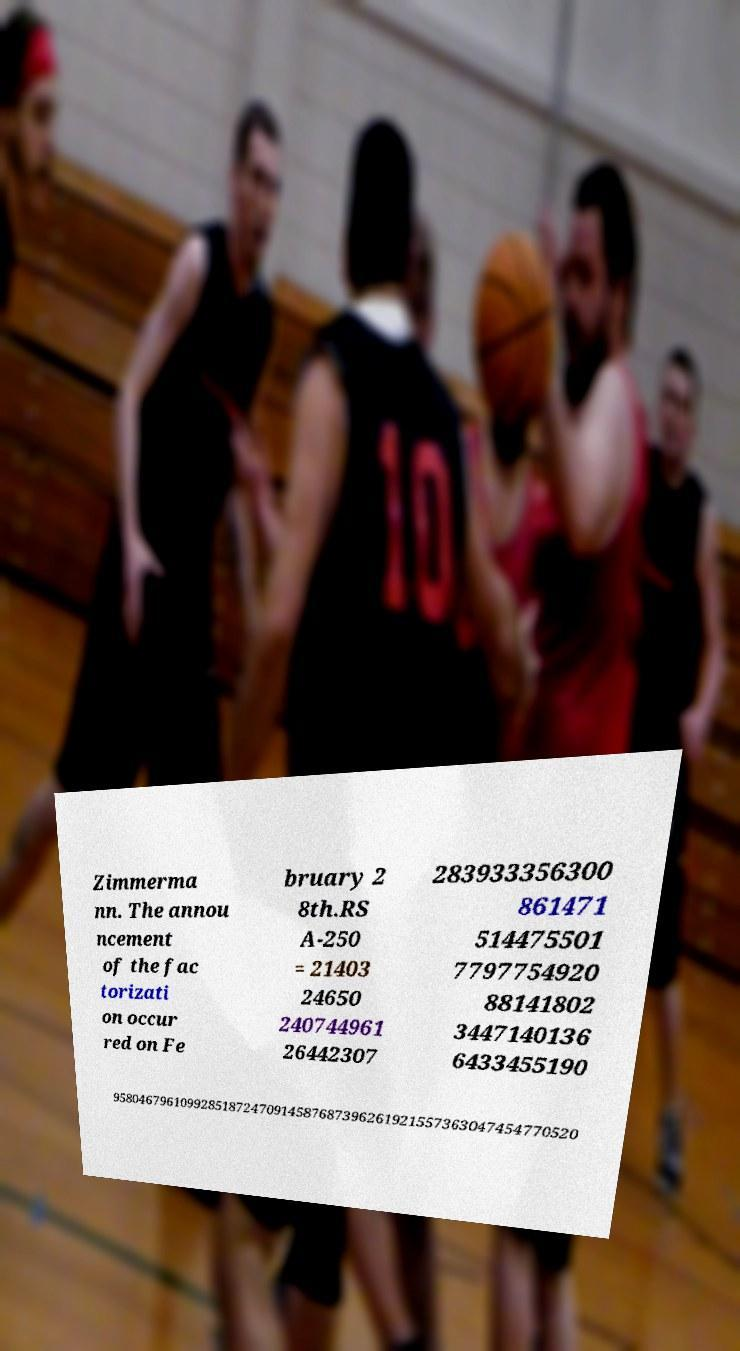Please identify and transcribe the text found in this image. Zimmerma nn. The annou ncement of the fac torizati on occur red on Fe bruary 2 8th.RS A-250 = 21403 24650 240744961 26442307 283933356300 861471 514475501 7797754920 88141802 3447140136 6433455190 95804679610992851872470914587687396261921557363047454770520 